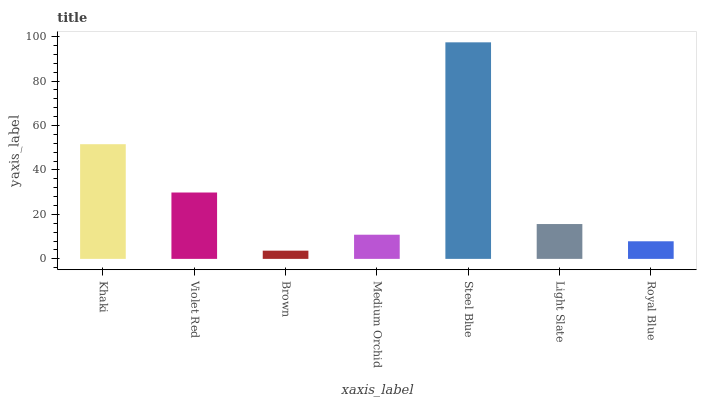Is Brown the minimum?
Answer yes or no. Yes. Is Steel Blue the maximum?
Answer yes or no. Yes. Is Violet Red the minimum?
Answer yes or no. No. Is Violet Red the maximum?
Answer yes or no. No. Is Khaki greater than Violet Red?
Answer yes or no. Yes. Is Violet Red less than Khaki?
Answer yes or no. Yes. Is Violet Red greater than Khaki?
Answer yes or no. No. Is Khaki less than Violet Red?
Answer yes or no. No. Is Light Slate the high median?
Answer yes or no. Yes. Is Light Slate the low median?
Answer yes or no. Yes. Is Medium Orchid the high median?
Answer yes or no. No. Is Khaki the low median?
Answer yes or no. No. 